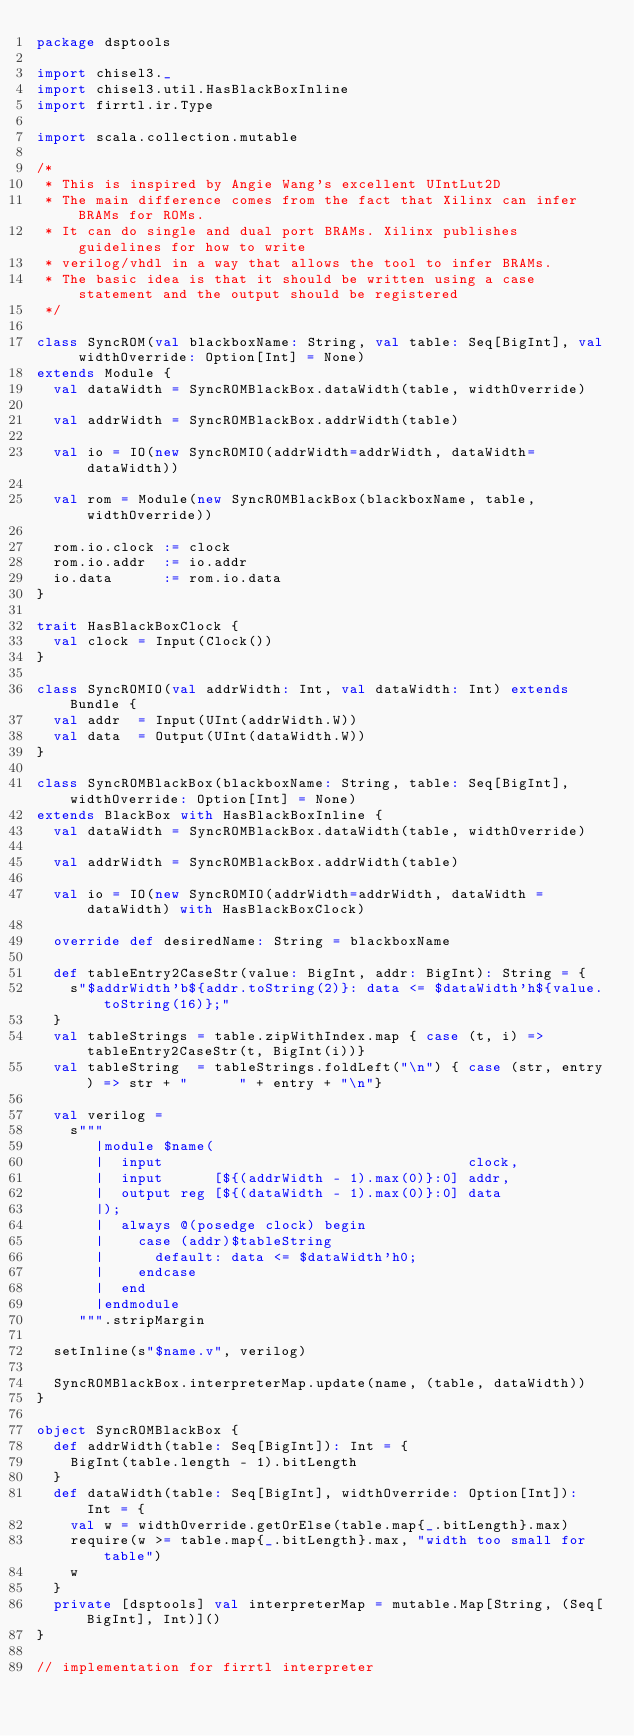Convert code to text. <code><loc_0><loc_0><loc_500><loc_500><_Scala_>package dsptools

import chisel3._
import chisel3.util.HasBlackBoxInline
import firrtl.ir.Type

import scala.collection.mutable

/*
 * This is inspired by Angie Wang's excellent UIntLut2D
 * The main difference comes from the fact that Xilinx can infer BRAMs for ROMs.
 * It can do single and dual port BRAMs. Xilinx publishes guidelines for how to write
 * verilog/vhdl in a way that allows the tool to infer BRAMs.
 * The basic idea is that it should be written using a case statement and the output should be registered
 */

class SyncROM(val blackboxName: String, val table: Seq[BigInt], val widthOverride: Option[Int] = None)
extends Module {
  val dataWidth = SyncROMBlackBox.dataWidth(table, widthOverride)

  val addrWidth = SyncROMBlackBox.addrWidth(table)

  val io = IO(new SyncROMIO(addrWidth=addrWidth, dataWidth=dataWidth))

  val rom = Module(new SyncROMBlackBox(blackboxName, table, widthOverride))

  rom.io.clock := clock
  rom.io.addr  := io.addr
  io.data      := rom.io.data
}

trait HasBlackBoxClock {
  val clock = Input(Clock())
}

class SyncROMIO(val addrWidth: Int, val dataWidth: Int) extends Bundle {
  val addr  = Input(UInt(addrWidth.W))
  val data  = Output(UInt(dataWidth.W))
}

class SyncROMBlackBox(blackboxName: String, table: Seq[BigInt], widthOverride: Option[Int] = None)
extends BlackBox with HasBlackBoxInline {
  val dataWidth = SyncROMBlackBox.dataWidth(table, widthOverride)

  val addrWidth = SyncROMBlackBox.addrWidth(table)

  val io = IO(new SyncROMIO(addrWidth=addrWidth, dataWidth = dataWidth) with HasBlackBoxClock)

  override def desiredName: String = blackboxName

  def tableEntry2CaseStr(value: BigInt, addr: BigInt): String = {
    s"$addrWidth'b${addr.toString(2)}: data <= $dataWidth'h${value.toString(16)};"
  }
  val tableStrings = table.zipWithIndex.map { case (t, i) => tableEntry2CaseStr(t, BigInt(i))}
  val tableString  = tableStrings.foldLeft("\n") { case (str, entry) => str + "      " + entry + "\n"}

  val verilog =
    s"""
       |module $name(
       |  input                                    clock,
       |  input      [${(addrWidth - 1).max(0)}:0] addr,
       |  output reg [${(dataWidth - 1).max(0)}:0] data
       |);
       |  always @(posedge clock) begin
       |    case (addr)$tableString
       |      default: data <= $dataWidth'h0;
       |    endcase
       |  end
       |endmodule
     """.stripMargin

  setInline(s"$name.v", verilog)

  SyncROMBlackBox.interpreterMap.update(name, (table, dataWidth))
}

object SyncROMBlackBox {
  def addrWidth(table: Seq[BigInt]): Int = {
    BigInt(table.length - 1).bitLength
  }
  def dataWidth(table: Seq[BigInt], widthOverride: Option[Int]): Int = {
    val w = widthOverride.getOrElse(table.map{_.bitLength}.max)
    require(w >= table.map{_.bitLength}.max, "width too small for table")
    w
  }
  private [dsptools] val interpreterMap = mutable.Map[String, (Seq[BigInt], Int)]()
}

// implementation for firrtl interpreter</code> 